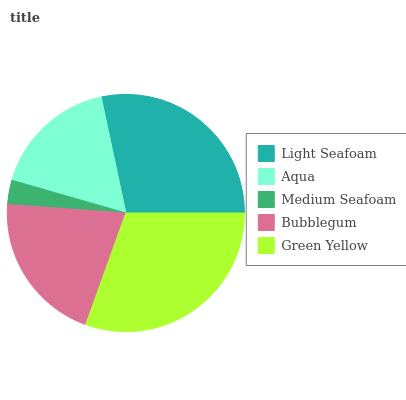Is Medium Seafoam the minimum?
Answer yes or no. Yes. Is Green Yellow the maximum?
Answer yes or no. Yes. Is Aqua the minimum?
Answer yes or no. No. Is Aqua the maximum?
Answer yes or no. No. Is Light Seafoam greater than Aqua?
Answer yes or no. Yes. Is Aqua less than Light Seafoam?
Answer yes or no. Yes. Is Aqua greater than Light Seafoam?
Answer yes or no. No. Is Light Seafoam less than Aqua?
Answer yes or no. No. Is Bubblegum the high median?
Answer yes or no. Yes. Is Bubblegum the low median?
Answer yes or no. Yes. Is Aqua the high median?
Answer yes or no. No. Is Medium Seafoam the low median?
Answer yes or no. No. 